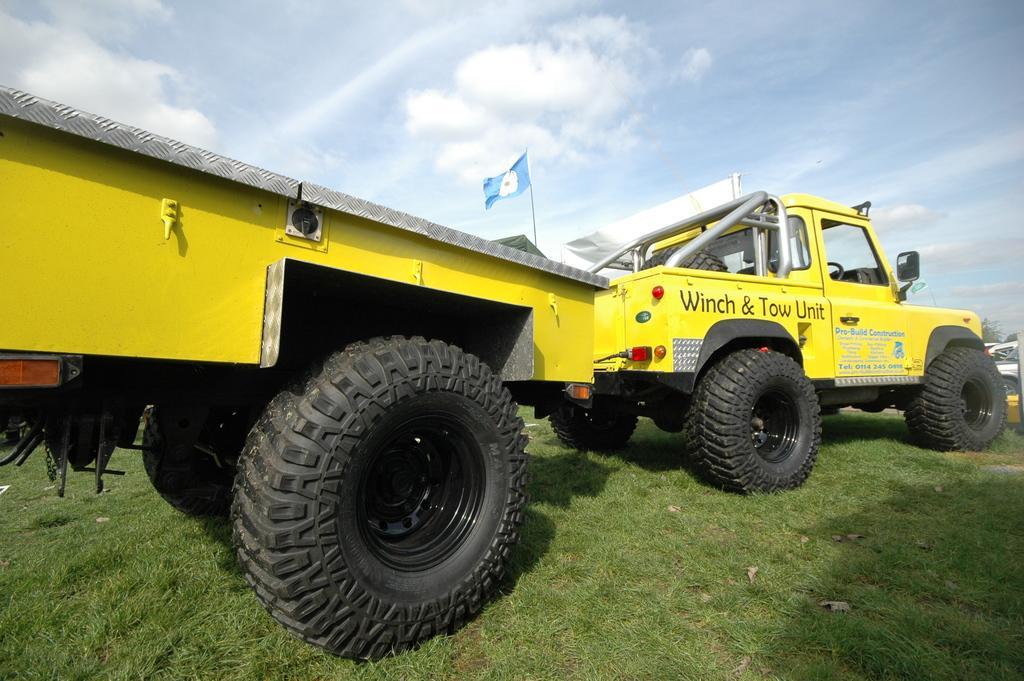Can you describe this image briefly? In this image I can see a yellow color of vehicle. In the background I can see a flag and a clear view of sky. 